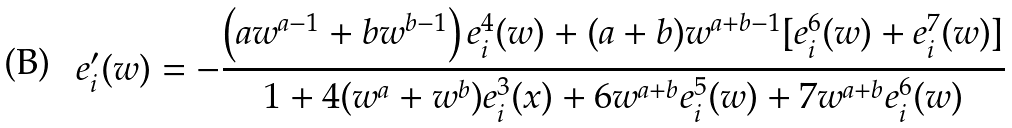<formula> <loc_0><loc_0><loc_500><loc_500>e ^ { \prime } _ { i } ( w ) = - \frac { \left ( a w ^ { a - 1 } + b w ^ { b - 1 } \right ) e ^ { 4 } _ { i } ( w ) + ( a + b ) w ^ { a + b - 1 } [ e ^ { 6 } _ { i } ( w ) + e ^ { 7 } _ { i } ( w ) ] } { 1 + 4 ( w ^ { a } + w ^ { b } ) e ^ { 3 } _ { i } ( x ) + 6 w ^ { a + b } e ^ { 5 } _ { i } ( w ) + 7 w ^ { a + b } e ^ { 6 } _ { i } ( w ) }</formula> 